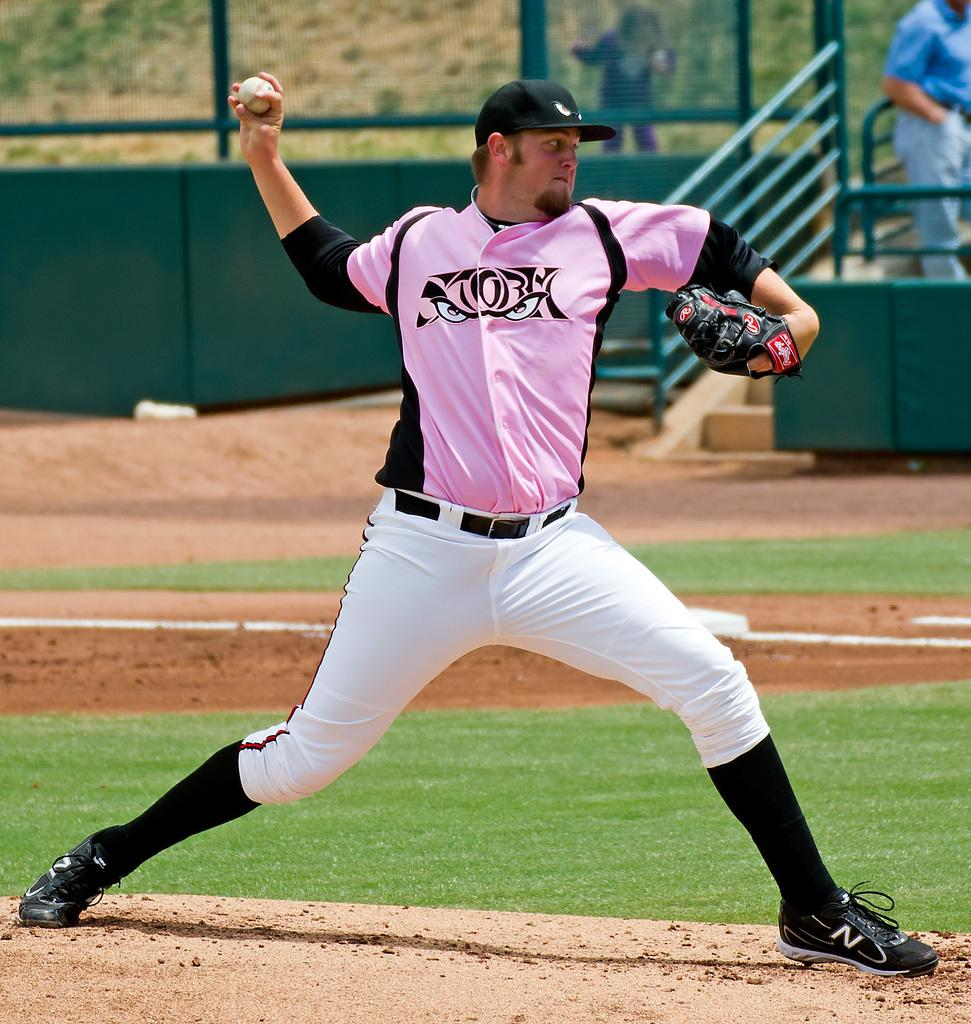<image>
Relay a brief, clear account of the picture shown. a storm jersey that has eyes on the graphic 